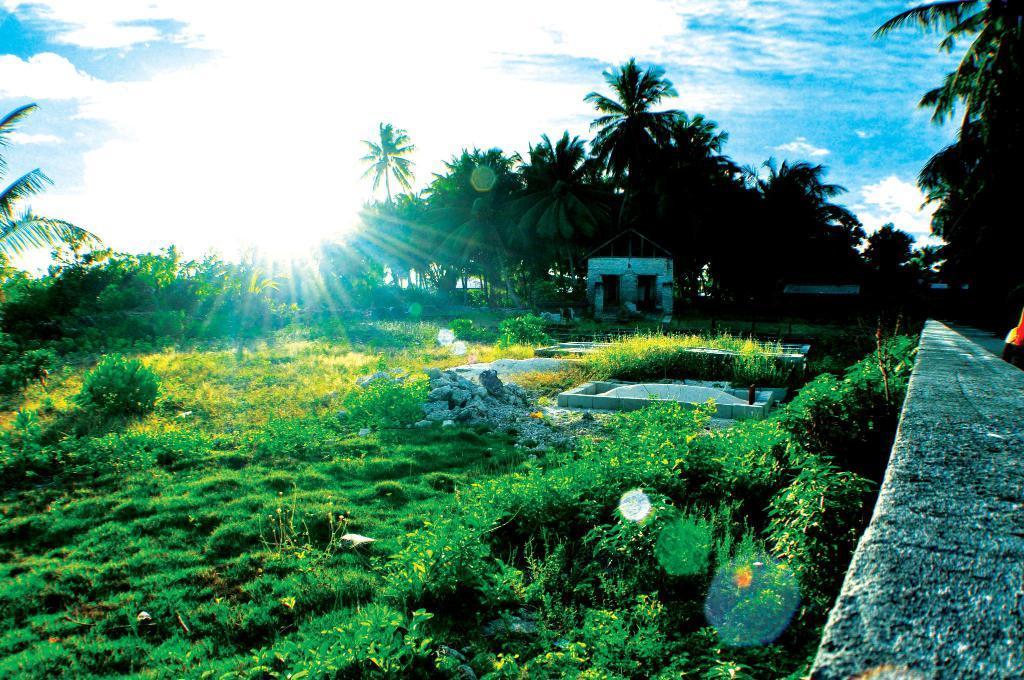Please provide a concise description of this image. In this picture we can see trees, stones, grass, wall and in the background we can see the sky with clouds. 